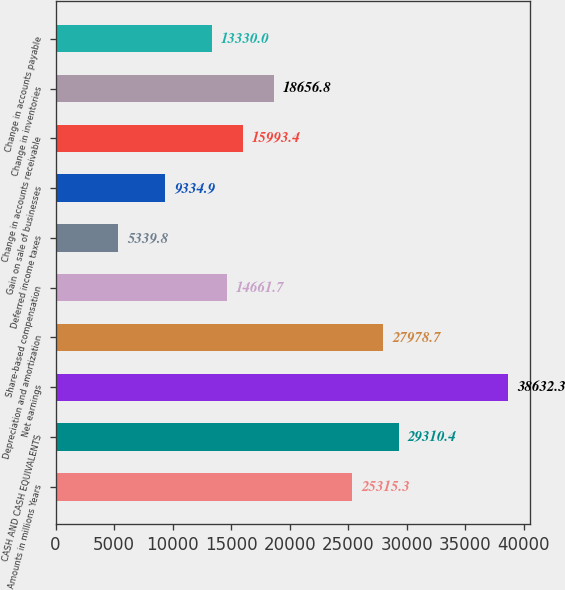<chart> <loc_0><loc_0><loc_500><loc_500><bar_chart><fcel>Amounts in millions Years<fcel>CASH AND CASH EQUIVALENTS<fcel>Net earnings<fcel>Depreciation and amortization<fcel>Share-based compensation<fcel>Deferred income taxes<fcel>Gain on sale of businesses<fcel>Change in accounts receivable<fcel>Change in inventories<fcel>Change in accounts payable<nl><fcel>25315.3<fcel>29310.4<fcel>38632.3<fcel>27978.7<fcel>14661.7<fcel>5339.8<fcel>9334.9<fcel>15993.4<fcel>18656.8<fcel>13330<nl></chart> 